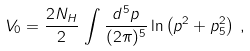<formula> <loc_0><loc_0><loc_500><loc_500>V _ { 0 } = \frac { 2 N _ { H } } { 2 } \, \int \frac { d ^ { 5 } p } { ( 2 \pi ) ^ { 5 } } \ln \left ( p ^ { 2 } + p _ { 5 } ^ { 2 } \right ) \, ,</formula> 